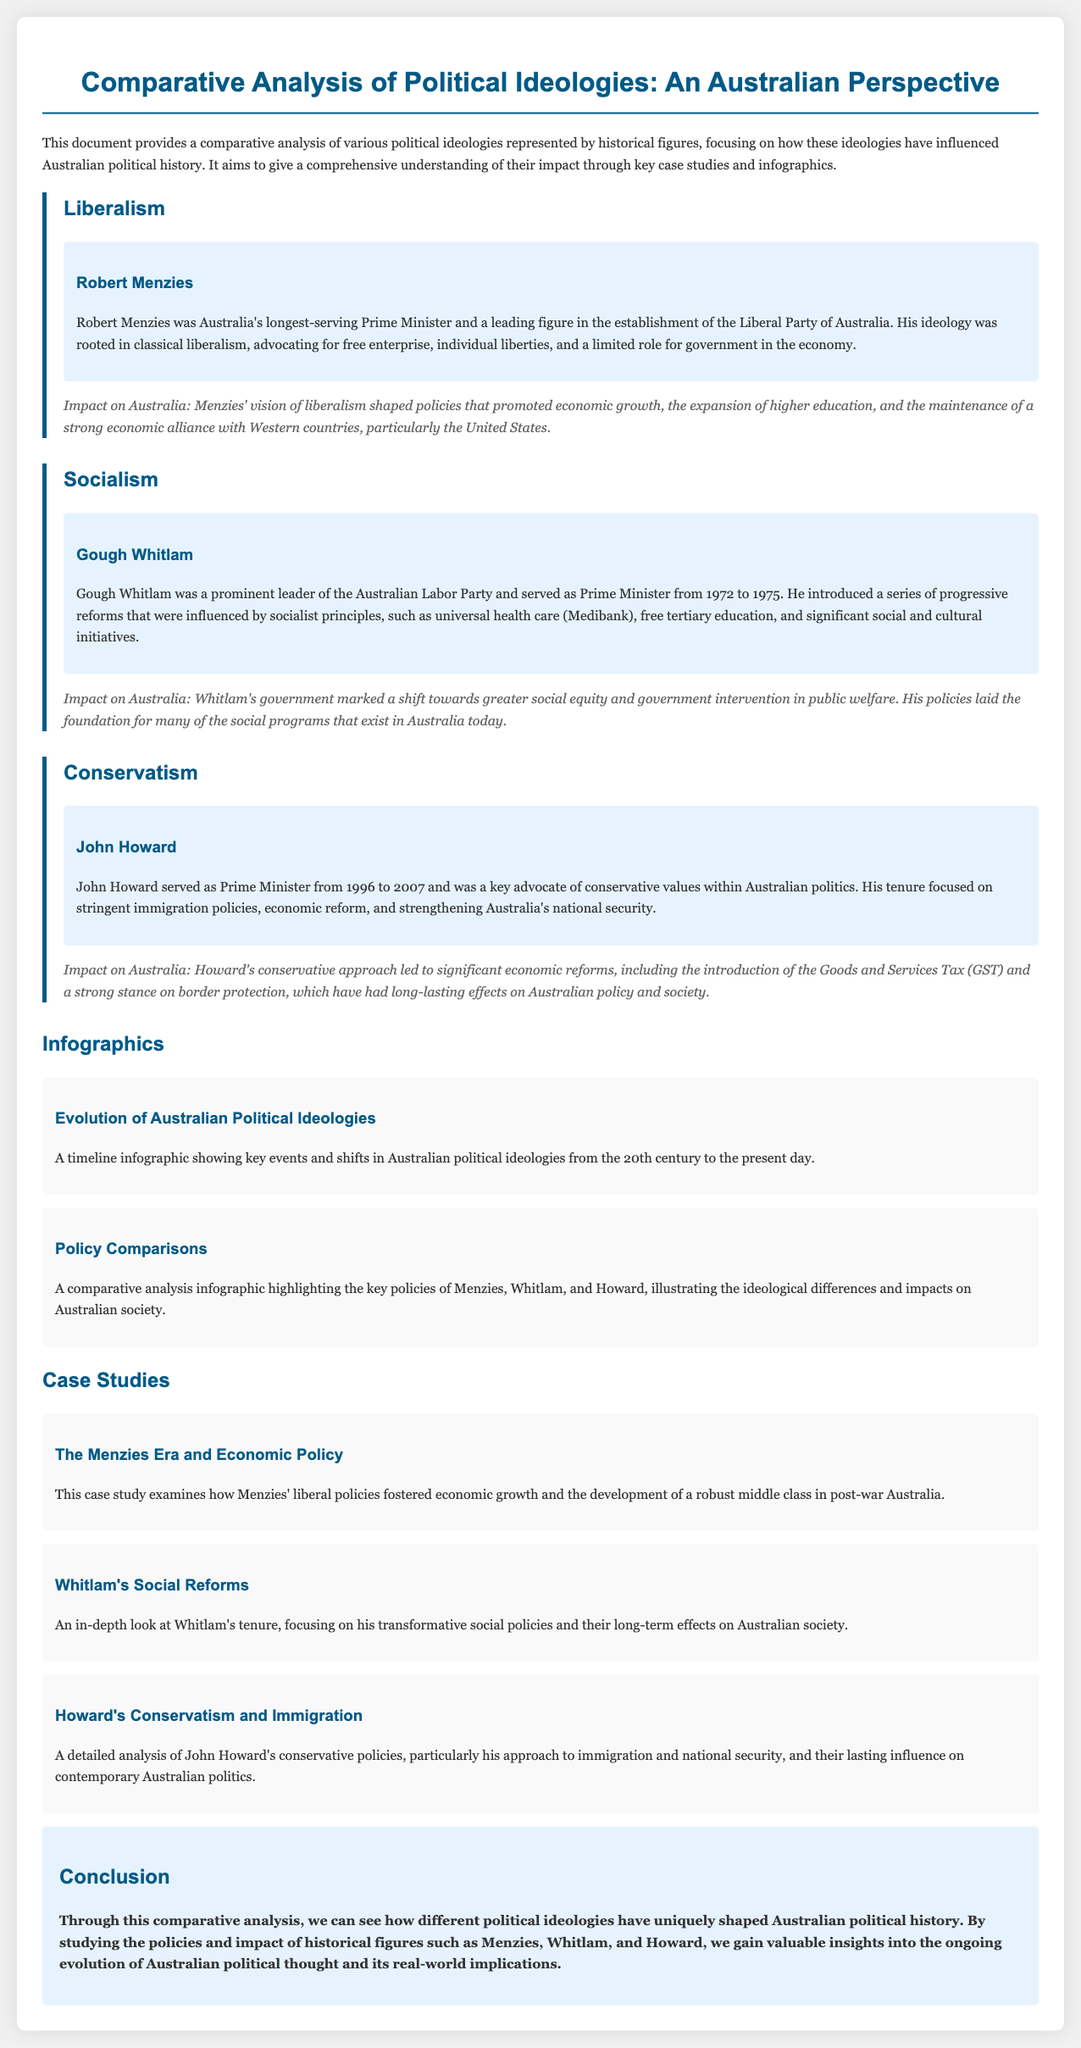What was Robert Menzies' political party? The document states that Robert Menzies was a leading figure in the establishment of the Liberal Party of Australia.
Answer: Liberal Party What unique social reforms did Gough Whitlam introduce? The document mentions that Whitlam introduced universal health care (Medibank) and free tertiary education as part of his progressive reforms.
Answer: universal health care, free tertiary education During which years did John Howard serve as Prime Minister? The document specifies that John Howard served as Prime Minister from 1996 to 2007.
Answer: 1996 to 2007 What impact did Menzies’ policies have on Australian society? The document describes Menzies' vision shaping policies that promoted economic growth and the expansion of higher education.
Answer: economic growth, higher education Which political ideology is associated with Gough Whitlam? The document states that Gough Whitlam's policies were influenced by socialist principles.
Answer: socialism What was a major outcome of Howard's conservative policies? The document notes that Howard's conservative approach led to significant economic reforms, including the Goods and Services Tax (GST).
Answer: Goods and Services Tax How does the document present information visually? The document includes infographics that highlight key policies and a timeline of events regarding Australian political ideologies.
Answer: infographics What type of analysis does this document provide? The document provides a comparative analysis of various political ideologies represented by historical figures.
Answer: comparative analysis Which historical figure focused on immigration policies? The document indicates that John Howard focused on stringent immigration policies during his tenure.
Answer: John Howard 